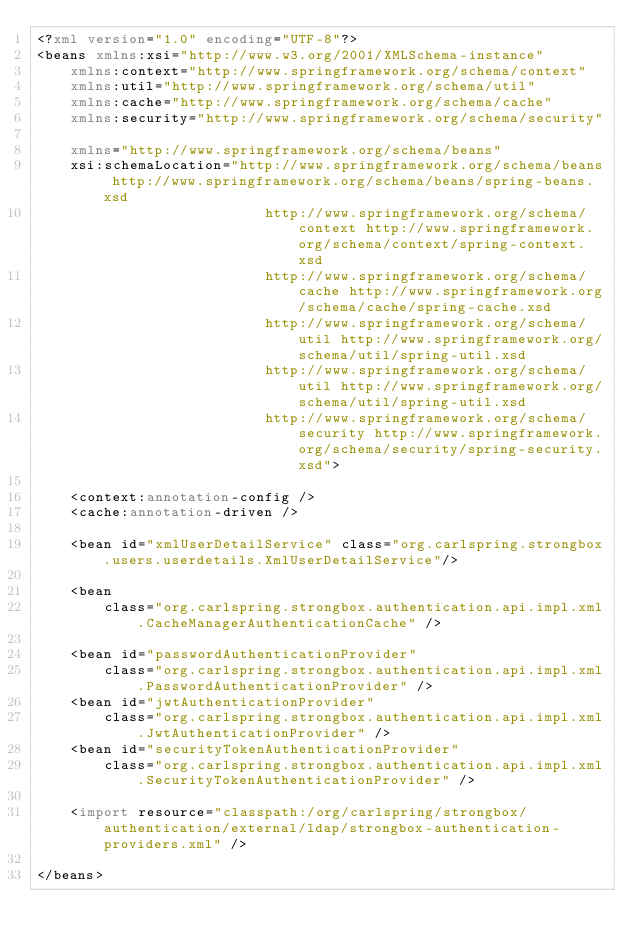<code> <loc_0><loc_0><loc_500><loc_500><_XML_><?xml version="1.0" encoding="UTF-8"?>
<beans xmlns:xsi="http://www.w3.org/2001/XMLSchema-instance"
    xmlns:context="http://www.springframework.org/schema/context"
    xmlns:util="http://www.springframework.org/schema/util"
    xmlns:cache="http://www.springframework.org/schema/cache"
    xmlns:security="http://www.springframework.org/schema/security"

    xmlns="http://www.springframework.org/schema/beans"
    xsi:schemaLocation="http://www.springframework.org/schema/beans http://www.springframework.org/schema/beans/spring-beans.xsd
                           http://www.springframework.org/schema/context http://www.springframework.org/schema/context/spring-context.xsd
                           http://www.springframework.org/schema/cache http://www.springframework.org/schema/cache/spring-cache.xsd
                           http://www.springframework.org/schema/util http://www.springframework.org/schema/util/spring-util.xsd
                           http://www.springframework.org/schema/util http://www.springframework.org/schema/util/spring-util.xsd
                           http://www.springframework.org/schema/security http://www.springframework.org/schema/security/spring-security.xsd">

    <context:annotation-config />
    <cache:annotation-driven />

    <bean id="xmlUserDetailService" class="org.carlspring.strongbox.users.userdetails.XmlUserDetailService"/>

    <bean
        class="org.carlspring.strongbox.authentication.api.impl.xml.CacheManagerAuthenticationCache" />

    <bean id="passwordAuthenticationProvider"
        class="org.carlspring.strongbox.authentication.api.impl.xml.PasswordAuthenticationProvider" />
    <bean id="jwtAuthenticationProvider"
        class="org.carlspring.strongbox.authentication.api.impl.xml.JwtAuthenticationProvider" />
    <bean id="securityTokenAuthenticationProvider"
        class="org.carlspring.strongbox.authentication.api.impl.xml.SecurityTokenAuthenticationProvider" />

    <import resource="classpath:/org/carlspring/strongbox/authentication/external/ldap/strongbox-authentication-providers.xml" />
    
</beans></code> 